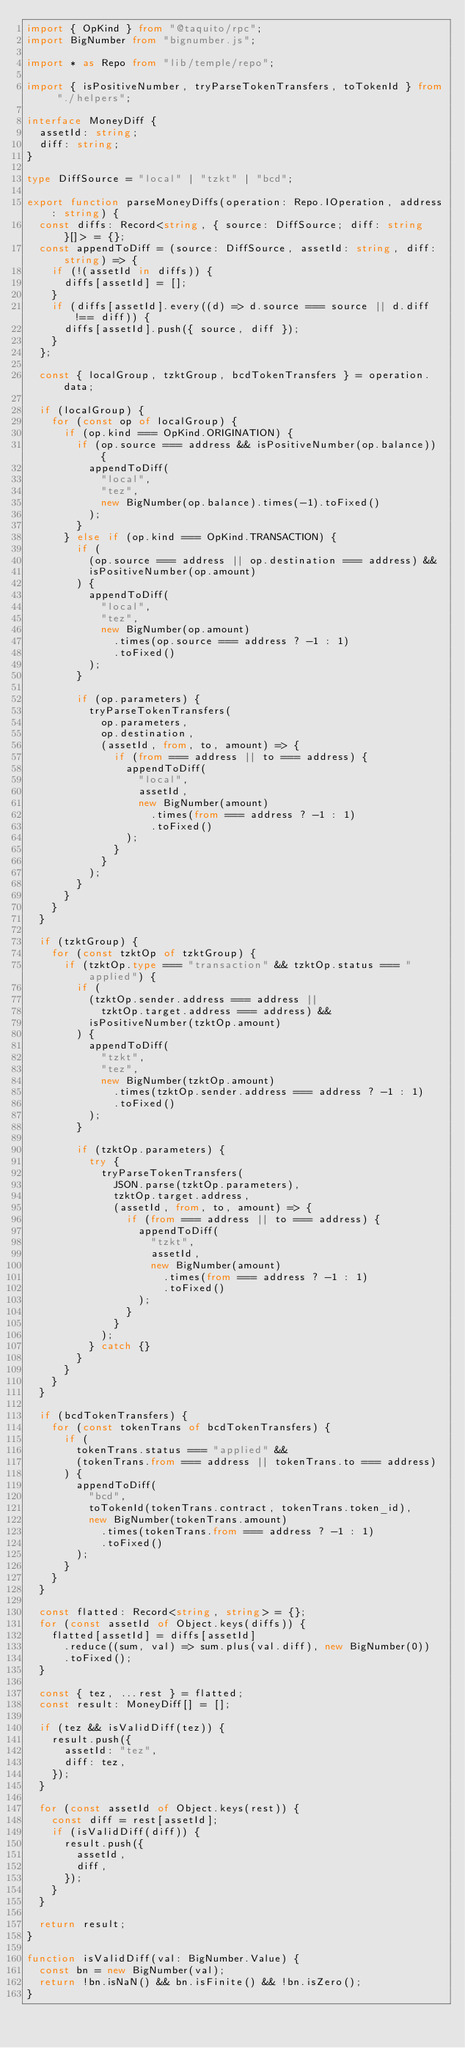<code> <loc_0><loc_0><loc_500><loc_500><_TypeScript_>import { OpKind } from "@taquito/rpc";
import BigNumber from "bignumber.js";

import * as Repo from "lib/temple/repo";

import { isPositiveNumber, tryParseTokenTransfers, toTokenId } from "./helpers";

interface MoneyDiff {
  assetId: string;
  diff: string;
}

type DiffSource = "local" | "tzkt" | "bcd";

export function parseMoneyDiffs(operation: Repo.IOperation, address: string) {
  const diffs: Record<string, { source: DiffSource; diff: string }[]> = {};
  const appendToDiff = (source: DiffSource, assetId: string, diff: string) => {
    if (!(assetId in diffs)) {
      diffs[assetId] = [];
    }
    if (diffs[assetId].every((d) => d.source === source || d.diff !== diff)) {
      diffs[assetId].push({ source, diff });
    }
  };

  const { localGroup, tzktGroup, bcdTokenTransfers } = operation.data;

  if (localGroup) {
    for (const op of localGroup) {
      if (op.kind === OpKind.ORIGINATION) {
        if (op.source === address && isPositiveNumber(op.balance)) {
          appendToDiff(
            "local",
            "tez",
            new BigNumber(op.balance).times(-1).toFixed()
          );
        }
      } else if (op.kind === OpKind.TRANSACTION) {
        if (
          (op.source === address || op.destination === address) &&
          isPositiveNumber(op.amount)
        ) {
          appendToDiff(
            "local",
            "tez",
            new BigNumber(op.amount)
              .times(op.source === address ? -1 : 1)
              .toFixed()
          );
        }

        if (op.parameters) {
          tryParseTokenTransfers(
            op.parameters,
            op.destination,
            (assetId, from, to, amount) => {
              if (from === address || to === address) {
                appendToDiff(
                  "local",
                  assetId,
                  new BigNumber(amount)
                    .times(from === address ? -1 : 1)
                    .toFixed()
                );
              }
            }
          );
        }
      }
    }
  }

  if (tzktGroup) {
    for (const tzktOp of tzktGroup) {
      if (tzktOp.type === "transaction" && tzktOp.status === "applied") {
        if (
          (tzktOp.sender.address === address ||
            tzktOp.target.address === address) &&
          isPositiveNumber(tzktOp.amount)
        ) {
          appendToDiff(
            "tzkt",
            "tez",
            new BigNumber(tzktOp.amount)
              .times(tzktOp.sender.address === address ? -1 : 1)
              .toFixed()
          );
        }

        if (tzktOp.parameters) {
          try {
            tryParseTokenTransfers(
              JSON.parse(tzktOp.parameters),
              tzktOp.target.address,
              (assetId, from, to, amount) => {
                if (from === address || to === address) {
                  appendToDiff(
                    "tzkt",
                    assetId,
                    new BigNumber(amount)
                      .times(from === address ? -1 : 1)
                      .toFixed()
                  );
                }
              }
            );
          } catch {}
        }
      }
    }
  }

  if (bcdTokenTransfers) {
    for (const tokenTrans of bcdTokenTransfers) {
      if (
        tokenTrans.status === "applied" &&
        (tokenTrans.from === address || tokenTrans.to === address)
      ) {
        appendToDiff(
          "bcd",
          toTokenId(tokenTrans.contract, tokenTrans.token_id),
          new BigNumber(tokenTrans.amount)
            .times(tokenTrans.from === address ? -1 : 1)
            .toFixed()
        );
      }
    }
  }

  const flatted: Record<string, string> = {};
  for (const assetId of Object.keys(diffs)) {
    flatted[assetId] = diffs[assetId]
      .reduce((sum, val) => sum.plus(val.diff), new BigNumber(0))
      .toFixed();
  }

  const { tez, ...rest } = flatted;
  const result: MoneyDiff[] = [];

  if (tez && isValidDiff(tez)) {
    result.push({
      assetId: "tez",
      diff: tez,
    });
  }

  for (const assetId of Object.keys(rest)) {
    const diff = rest[assetId];
    if (isValidDiff(diff)) {
      result.push({
        assetId,
        diff,
      });
    }
  }

  return result;
}

function isValidDiff(val: BigNumber.Value) {
  const bn = new BigNumber(val);
  return !bn.isNaN() && bn.isFinite() && !bn.isZero();
}
</code> 